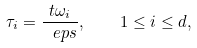<formula> <loc_0><loc_0><loc_500><loc_500>\tau _ { i } = \frac { t \omega _ { i } } { \ e p s } , \quad 1 \leq i \leq d ,</formula> 